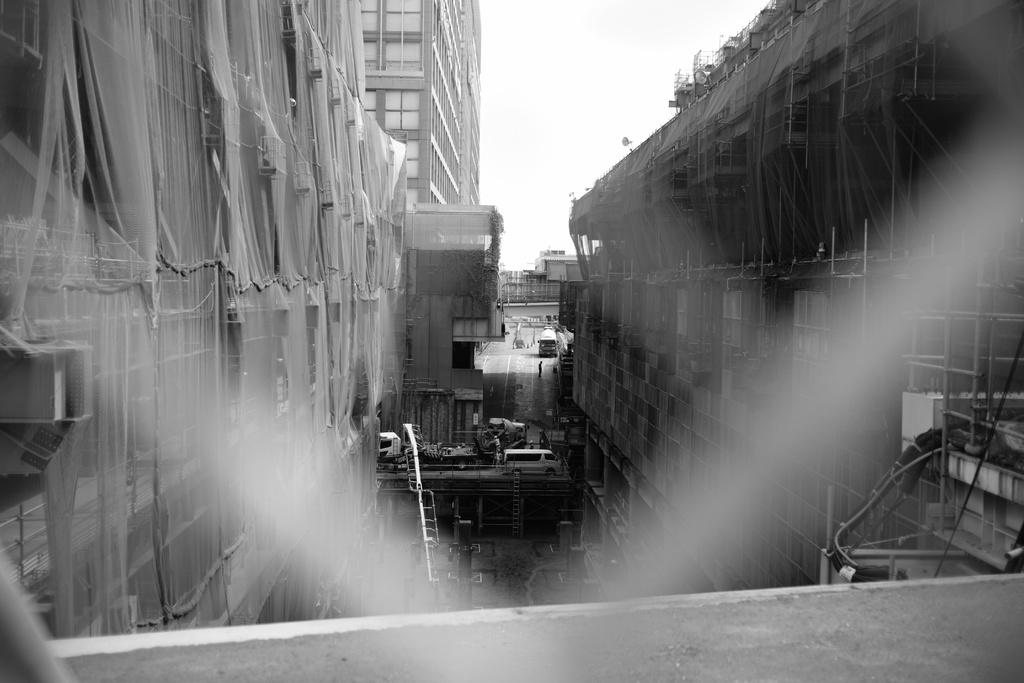What type of structures can be seen in the image? There are buildings in the image. What feature can be observed on the buildings in the foreground? Nets are present on the buildings in the foreground. What else can be seen in the background of the image? Vehicles are visible in the background. What is visible at the top of the image? The sky is visible at the top of the image. What type of farm animals can be seen playing with toys in the image? There is no farm or toys present in the image; it features buildings with nets and vehicles in the background. 